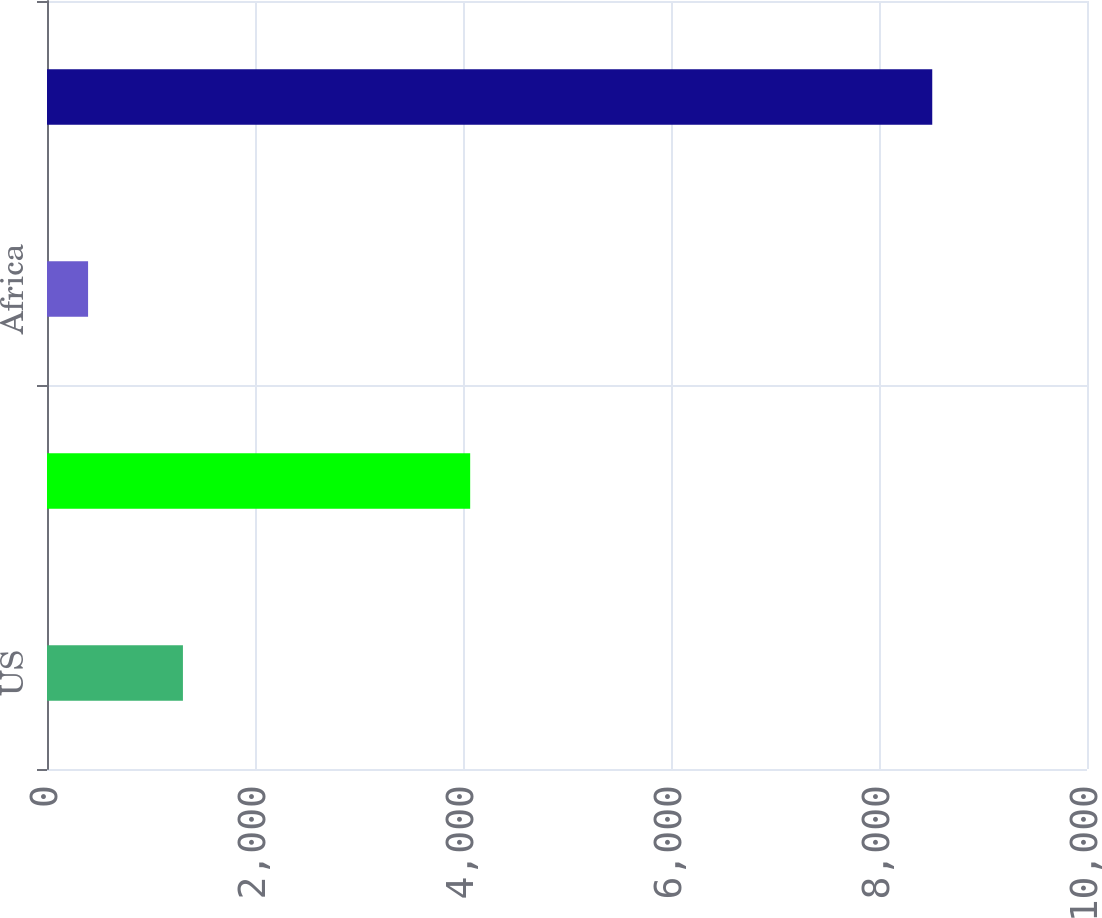Convert chart. <chart><loc_0><loc_0><loc_500><loc_500><bar_chart><fcel>US<fcel>Indonesia<fcel>Africa<fcel>Consolidated FCX<nl><fcel>1307<fcel>4069<fcel>395<fcel>8512<nl></chart> 